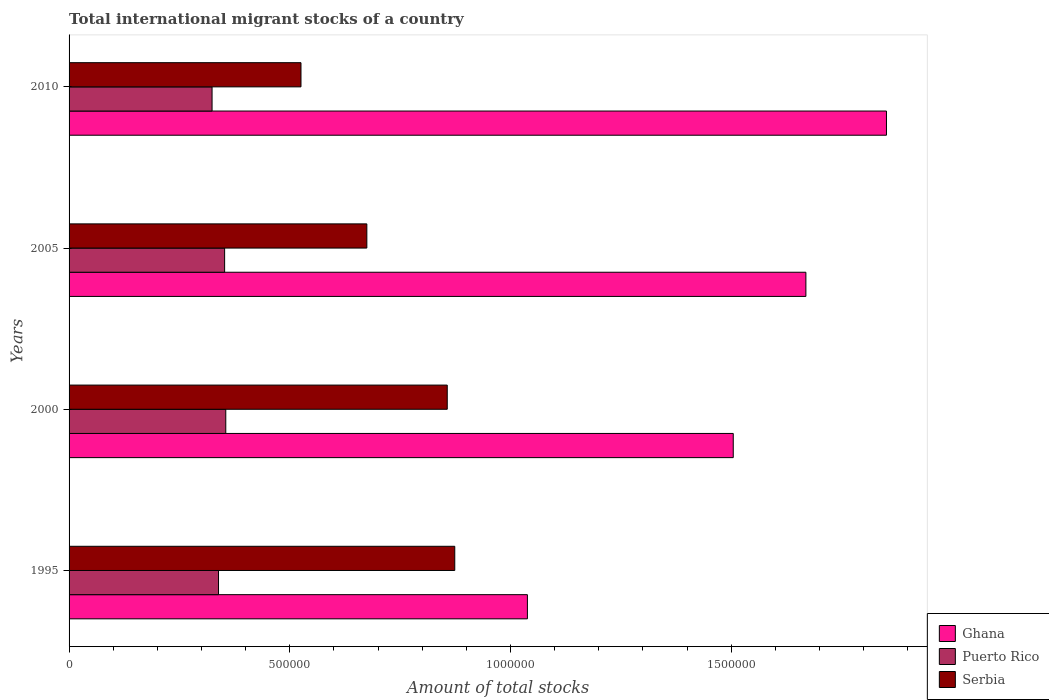How many groups of bars are there?
Offer a terse response. 4. Are the number of bars per tick equal to the number of legend labels?
Your response must be concise. Yes. How many bars are there on the 3rd tick from the top?
Your answer should be very brief. 3. How many bars are there on the 1st tick from the bottom?
Your answer should be very brief. 3. What is the label of the 4th group of bars from the top?
Offer a terse response. 1995. In how many cases, is the number of bars for a given year not equal to the number of legend labels?
Your response must be concise. 0. What is the amount of total stocks in in Ghana in 2000?
Provide a succinct answer. 1.50e+06. Across all years, what is the maximum amount of total stocks in in Ghana?
Provide a short and direct response. 1.85e+06. Across all years, what is the minimum amount of total stocks in in Ghana?
Keep it short and to the point. 1.04e+06. In which year was the amount of total stocks in in Serbia maximum?
Offer a terse response. 1995. In which year was the amount of total stocks in in Serbia minimum?
Your answer should be compact. 2010. What is the total amount of total stocks in in Serbia in the graph?
Offer a terse response. 2.93e+06. What is the difference between the amount of total stocks in in Ghana in 1995 and that in 2000?
Your answer should be very brief. -4.66e+05. What is the difference between the amount of total stocks in in Ghana in 2000 and the amount of total stocks in in Serbia in 1995?
Your response must be concise. 6.31e+05. What is the average amount of total stocks in in Serbia per year?
Offer a very short reply. 7.33e+05. In the year 2000, what is the difference between the amount of total stocks in in Puerto Rico and amount of total stocks in in Serbia?
Provide a succinct answer. -5.02e+05. In how many years, is the amount of total stocks in in Puerto Rico greater than 800000 ?
Provide a succinct answer. 0. What is the ratio of the amount of total stocks in in Ghana in 1995 to that in 2005?
Your response must be concise. 0.62. What is the difference between the highest and the second highest amount of total stocks in in Puerto Rico?
Provide a succinct answer. 2632. What is the difference between the highest and the lowest amount of total stocks in in Ghana?
Your answer should be compact. 8.13e+05. In how many years, is the amount of total stocks in in Serbia greater than the average amount of total stocks in in Serbia taken over all years?
Provide a succinct answer. 2. What does the 2nd bar from the top in 2000 represents?
Keep it short and to the point. Puerto Rico. What does the 2nd bar from the bottom in 2005 represents?
Your answer should be compact. Puerto Rico. How many bars are there?
Your answer should be compact. 12. How many years are there in the graph?
Give a very brief answer. 4. What is the difference between two consecutive major ticks on the X-axis?
Your response must be concise. 5.00e+05. Are the values on the major ticks of X-axis written in scientific E-notation?
Give a very brief answer. No. Does the graph contain any zero values?
Your answer should be very brief. No. Does the graph contain grids?
Provide a succinct answer. No. What is the title of the graph?
Keep it short and to the point. Total international migrant stocks of a country. Does "Puerto Rico" appear as one of the legend labels in the graph?
Give a very brief answer. Yes. What is the label or title of the X-axis?
Provide a short and direct response. Amount of total stocks. What is the Amount of total stocks in Ghana in 1995?
Provide a succinct answer. 1.04e+06. What is the Amount of total stocks in Puerto Rico in 1995?
Your answer should be very brief. 3.39e+05. What is the Amount of total stocks of Serbia in 1995?
Provide a short and direct response. 8.74e+05. What is the Amount of total stocks in Ghana in 2000?
Give a very brief answer. 1.50e+06. What is the Amount of total stocks in Puerto Rico in 2000?
Your answer should be compact. 3.55e+05. What is the Amount of total stocks in Serbia in 2000?
Ensure brevity in your answer.  8.57e+05. What is the Amount of total stocks in Ghana in 2005?
Your answer should be compact. 1.67e+06. What is the Amount of total stocks of Puerto Rico in 2005?
Ensure brevity in your answer.  3.52e+05. What is the Amount of total stocks in Serbia in 2005?
Give a very brief answer. 6.75e+05. What is the Amount of total stocks of Ghana in 2010?
Offer a terse response. 1.85e+06. What is the Amount of total stocks in Puerto Rico in 2010?
Give a very brief answer. 3.24e+05. What is the Amount of total stocks in Serbia in 2010?
Provide a succinct answer. 5.25e+05. Across all years, what is the maximum Amount of total stocks in Ghana?
Give a very brief answer. 1.85e+06. Across all years, what is the maximum Amount of total stocks in Puerto Rico?
Offer a very short reply. 3.55e+05. Across all years, what is the maximum Amount of total stocks of Serbia?
Offer a very short reply. 8.74e+05. Across all years, what is the minimum Amount of total stocks of Ghana?
Make the answer very short. 1.04e+06. Across all years, what is the minimum Amount of total stocks of Puerto Rico?
Your answer should be very brief. 3.24e+05. Across all years, what is the minimum Amount of total stocks of Serbia?
Ensure brevity in your answer.  5.25e+05. What is the total Amount of total stocks of Ghana in the graph?
Ensure brevity in your answer.  6.06e+06. What is the total Amount of total stocks in Puerto Rico in the graph?
Your answer should be compact. 1.37e+06. What is the total Amount of total stocks of Serbia in the graph?
Offer a very short reply. 2.93e+06. What is the difference between the Amount of total stocks in Ghana in 1995 and that in 2000?
Give a very brief answer. -4.66e+05. What is the difference between the Amount of total stocks of Puerto Rico in 1995 and that in 2000?
Offer a terse response. -1.65e+04. What is the difference between the Amount of total stocks of Serbia in 1995 and that in 2000?
Your answer should be compact. 1.70e+04. What is the difference between the Amount of total stocks of Ghana in 1995 and that in 2005?
Ensure brevity in your answer.  -6.31e+05. What is the difference between the Amount of total stocks of Puerto Rico in 1995 and that in 2005?
Provide a succinct answer. -1.39e+04. What is the difference between the Amount of total stocks in Serbia in 1995 and that in 2005?
Offer a very short reply. 1.99e+05. What is the difference between the Amount of total stocks in Ghana in 1995 and that in 2010?
Give a very brief answer. -8.13e+05. What is the difference between the Amount of total stocks in Puerto Rico in 1995 and that in 2010?
Give a very brief answer. 1.46e+04. What is the difference between the Amount of total stocks of Serbia in 1995 and that in 2010?
Provide a short and direct response. 3.48e+05. What is the difference between the Amount of total stocks of Ghana in 2000 and that in 2005?
Your response must be concise. -1.65e+05. What is the difference between the Amount of total stocks in Puerto Rico in 2000 and that in 2005?
Make the answer very short. 2632. What is the difference between the Amount of total stocks of Serbia in 2000 and that in 2005?
Your response must be concise. 1.82e+05. What is the difference between the Amount of total stocks in Ghana in 2000 and that in 2010?
Provide a short and direct response. -3.47e+05. What is the difference between the Amount of total stocks in Puerto Rico in 2000 and that in 2010?
Your answer should be very brief. 3.11e+04. What is the difference between the Amount of total stocks of Serbia in 2000 and that in 2010?
Provide a short and direct response. 3.31e+05. What is the difference between the Amount of total stocks in Ghana in 2005 and that in 2010?
Ensure brevity in your answer.  -1.83e+05. What is the difference between the Amount of total stocks in Puerto Rico in 2005 and that in 2010?
Your answer should be very brief. 2.84e+04. What is the difference between the Amount of total stocks in Serbia in 2005 and that in 2010?
Make the answer very short. 1.49e+05. What is the difference between the Amount of total stocks of Ghana in 1995 and the Amount of total stocks of Puerto Rico in 2000?
Your response must be concise. 6.83e+05. What is the difference between the Amount of total stocks in Ghana in 1995 and the Amount of total stocks in Serbia in 2000?
Offer a very short reply. 1.82e+05. What is the difference between the Amount of total stocks in Puerto Rico in 1995 and the Amount of total stocks in Serbia in 2000?
Offer a terse response. -5.18e+05. What is the difference between the Amount of total stocks in Ghana in 1995 and the Amount of total stocks in Puerto Rico in 2005?
Your answer should be compact. 6.86e+05. What is the difference between the Amount of total stocks of Ghana in 1995 and the Amount of total stocks of Serbia in 2005?
Offer a very short reply. 3.64e+05. What is the difference between the Amount of total stocks in Puerto Rico in 1995 and the Amount of total stocks in Serbia in 2005?
Ensure brevity in your answer.  -3.36e+05. What is the difference between the Amount of total stocks in Ghana in 1995 and the Amount of total stocks in Puerto Rico in 2010?
Provide a succinct answer. 7.14e+05. What is the difference between the Amount of total stocks of Ghana in 1995 and the Amount of total stocks of Serbia in 2010?
Keep it short and to the point. 5.13e+05. What is the difference between the Amount of total stocks of Puerto Rico in 1995 and the Amount of total stocks of Serbia in 2010?
Provide a short and direct response. -1.87e+05. What is the difference between the Amount of total stocks of Ghana in 2000 and the Amount of total stocks of Puerto Rico in 2005?
Offer a terse response. 1.15e+06. What is the difference between the Amount of total stocks of Ghana in 2000 and the Amount of total stocks of Serbia in 2005?
Provide a short and direct response. 8.30e+05. What is the difference between the Amount of total stocks in Puerto Rico in 2000 and the Amount of total stocks in Serbia in 2005?
Provide a succinct answer. -3.20e+05. What is the difference between the Amount of total stocks of Ghana in 2000 and the Amount of total stocks of Puerto Rico in 2010?
Keep it short and to the point. 1.18e+06. What is the difference between the Amount of total stocks in Ghana in 2000 and the Amount of total stocks in Serbia in 2010?
Keep it short and to the point. 9.79e+05. What is the difference between the Amount of total stocks in Puerto Rico in 2000 and the Amount of total stocks in Serbia in 2010?
Ensure brevity in your answer.  -1.70e+05. What is the difference between the Amount of total stocks in Ghana in 2005 and the Amount of total stocks in Puerto Rico in 2010?
Offer a terse response. 1.35e+06. What is the difference between the Amount of total stocks of Ghana in 2005 and the Amount of total stocks of Serbia in 2010?
Your answer should be compact. 1.14e+06. What is the difference between the Amount of total stocks of Puerto Rico in 2005 and the Amount of total stocks of Serbia in 2010?
Your answer should be very brief. -1.73e+05. What is the average Amount of total stocks in Ghana per year?
Your answer should be very brief. 1.52e+06. What is the average Amount of total stocks in Puerto Rico per year?
Give a very brief answer. 3.42e+05. What is the average Amount of total stocks in Serbia per year?
Your response must be concise. 7.33e+05. In the year 1995, what is the difference between the Amount of total stocks in Ghana and Amount of total stocks in Puerto Rico?
Your answer should be very brief. 7.00e+05. In the year 1995, what is the difference between the Amount of total stocks of Ghana and Amount of total stocks of Serbia?
Keep it short and to the point. 1.65e+05. In the year 1995, what is the difference between the Amount of total stocks in Puerto Rico and Amount of total stocks in Serbia?
Your answer should be very brief. -5.35e+05. In the year 2000, what is the difference between the Amount of total stocks in Ghana and Amount of total stocks in Puerto Rico?
Provide a short and direct response. 1.15e+06. In the year 2000, what is the difference between the Amount of total stocks in Ghana and Amount of total stocks in Serbia?
Make the answer very short. 6.48e+05. In the year 2000, what is the difference between the Amount of total stocks of Puerto Rico and Amount of total stocks of Serbia?
Your answer should be very brief. -5.02e+05. In the year 2005, what is the difference between the Amount of total stocks in Ghana and Amount of total stocks in Puerto Rico?
Give a very brief answer. 1.32e+06. In the year 2005, what is the difference between the Amount of total stocks in Ghana and Amount of total stocks in Serbia?
Offer a terse response. 9.95e+05. In the year 2005, what is the difference between the Amount of total stocks in Puerto Rico and Amount of total stocks in Serbia?
Your answer should be compact. -3.22e+05. In the year 2010, what is the difference between the Amount of total stocks of Ghana and Amount of total stocks of Puerto Rico?
Make the answer very short. 1.53e+06. In the year 2010, what is the difference between the Amount of total stocks in Ghana and Amount of total stocks in Serbia?
Offer a very short reply. 1.33e+06. In the year 2010, what is the difference between the Amount of total stocks of Puerto Rico and Amount of total stocks of Serbia?
Keep it short and to the point. -2.01e+05. What is the ratio of the Amount of total stocks of Ghana in 1995 to that in 2000?
Give a very brief answer. 0.69. What is the ratio of the Amount of total stocks in Puerto Rico in 1995 to that in 2000?
Your response must be concise. 0.95. What is the ratio of the Amount of total stocks in Serbia in 1995 to that in 2000?
Offer a very short reply. 1.02. What is the ratio of the Amount of total stocks of Ghana in 1995 to that in 2005?
Provide a short and direct response. 0.62. What is the ratio of the Amount of total stocks of Puerto Rico in 1995 to that in 2005?
Provide a succinct answer. 0.96. What is the ratio of the Amount of total stocks of Serbia in 1995 to that in 2005?
Offer a terse response. 1.3. What is the ratio of the Amount of total stocks in Ghana in 1995 to that in 2010?
Keep it short and to the point. 0.56. What is the ratio of the Amount of total stocks of Puerto Rico in 1995 to that in 2010?
Provide a short and direct response. 1.04. What is the ratio of the Amount of total stocks of Serbia in 1995 to that in 2010?
Give a very brief answer. 1.66. What is the ratio of the Amount of total stocks in Ghana in 2000 to that in 2005?
Offer a very short reply. 0.9. What is the ratio of the Amount of total stocks in Puerto Rico in 2000 to that in 2005?
Ensure brevity in your answer.  1.01. What is the ratio of the Amount of total stocks of Serbia in 2000 to that in 2005?
Make the answer very short. 1.27. What is the ratio of the Amount of total stocks in Ghana in 2000 to that in 2010?
Make the answer very short. 0.81. What is the ratio of the Amount of total stocks in Puerto Rico in 2000 to that in 2010?
Your response must be concise. 1.1. What is the ratio of the Amount of total stocks in Serbia in 2000 to that in 2010?
Make the answer very short. 1.63. What is the ratio of the Amount of total stocks in Ghana in 2005 to that in 2010?
Make the answer very short. 0.9. What is the ratio of the Amount of total stocks of Puerto Rico in 2005 to that in 2010?
Your answer should be compact. 1.09. What is the ratio of the Amount of total stocks of Serbia in 2005 to that in 2010?
Offer a very short reply. 1.28. What is the difference between the highest and the second highest Amount of total stocks in Ghana?
Keep it short and to the point. 1.83e+05. What is the difference between the highest and the second highest Amount of total stocks in Puerto Rico?
Keep it short and to the point. 2632. What is the difference between the highest and the second highest Amount of total stocks of Serbia?
Ensure brevity in your answer.  1.70e+04. What is the difference between the highest and the lowest Amount of total stocks of Ghana?
Ensure brevity in your answer.  8.13e+05. What is the difference between the highest and the lowest Amount of total stocks in Puerto Rico?
Your response must be concise. 3.11e+04. What is the difference between the highest and the lowest Amount of total stocks of Serbia?
Your answer should be very brief. 3.48e+05. 